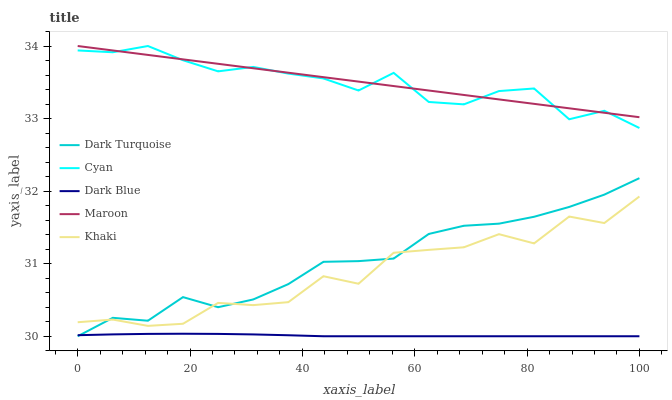Does Dark Blue have the minimum area under the curve?
Answer yes or no. Yes. Does Maroon have the maximum area under the curve?
Answer yes or no. Yes. Does Khaki have the minimum area under the curve?
Answer yes or no. No. Does Khaki have the maximum area under the curve?
Answer yes or no. No. Is Maroon the smoothest?
Answer yes or no. Yes. Is Khaki the roughest?
Answer yes or no. Yes. Is Dark Blue the smoothest?
Answer yes or no. No. Is Dark Blue the roughest?
Answer yes or no. No. Does Khaki have the lowest value?
Answer yes or no. No. Does Khaki have the highest value?
Answer yes or no. No. Is Dark Blue less than Cyan?
Answer yes or no. Yes. Is Cyan greater than Khaki?
Answer yes or no. Yes. Does Dark Blue intersect Cyan?
Answer yes or no. No. 